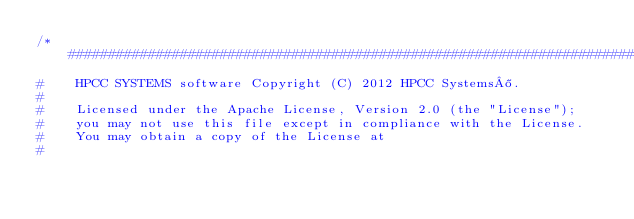Convert code to text. <code><loc_0><loc_0><loc_500><loc_500><_JavaScript_>/*##############################################################################
#    HPCC SYSTEMS software Copyright (C) 2012 HPCC Systems®.
#
#    Licensed under the Apache License, Version 2.0 (the "License");
#    you may not use this file except in compliance with the License.
#    You may obtain a copy of the License at
#</code> 